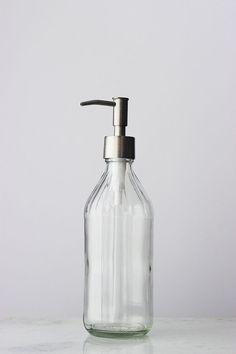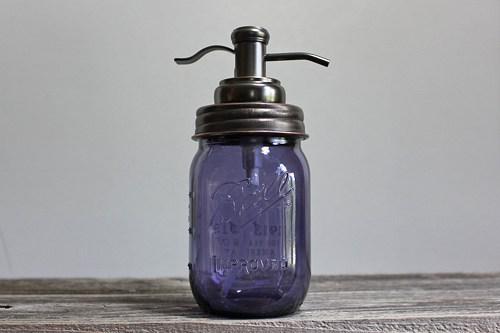The first image is the image on the left, the second image is the image on the right. For the images displayed, is the sentence "There are two bottles total from both images." factually correct? Answer yes or no. Yes. 